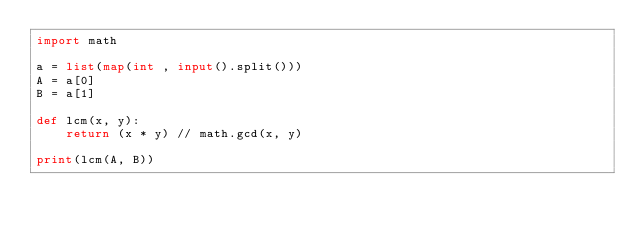Convert code to text. <code><loc_0><loc_0><loc_500><loc_500><_Python_>import math

a = list(map(int , input().split()))
A = a[0]
B = a[1]

def lcm(x, y):
    return (x * y) // math.gcd(x, y)

print(lcm(A, B))</code> 